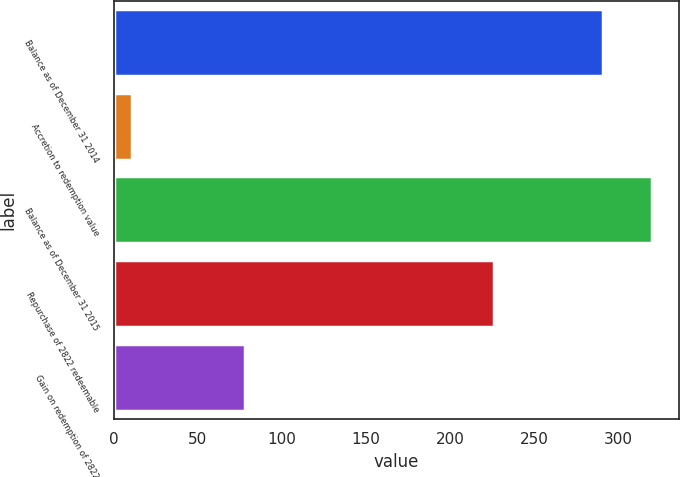Convert chart to OTSL. <chart><loc_0><loc_0><loc_500><loc_500><bar_chart><fcel>Balance as of December 31 2014<fcel>Accretion to redemption value<fcel>Balance as of December 31 2015<fcel>Repurchase of 2822 redeemable<fcel>Gain on redemption of 2822<nl><fcel>291<fcel>11<fcel>320.1<fcel>226<fcel>78<nl></chart> 